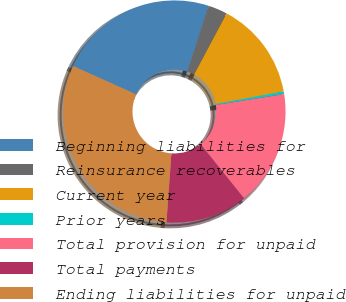Convert chart to OTSL. <chart><loc_0><loc_0><loc_500><loc_500><pie_chart><fcel>Beginning liabilities for<fcel>Reinsurance recoverables<fcel>Current year<fcel>Prior years<fcel>Total provision for unpaid<fcel>Total payments<fcel>Ending liabilities for unpaid<nl><fcel>23.28%<fcel>2.8%<fcel>14.33%<fcel>0.37%<fcel>16.76%<fcel>11.9%<fcel>30.57%<nl></chart> 